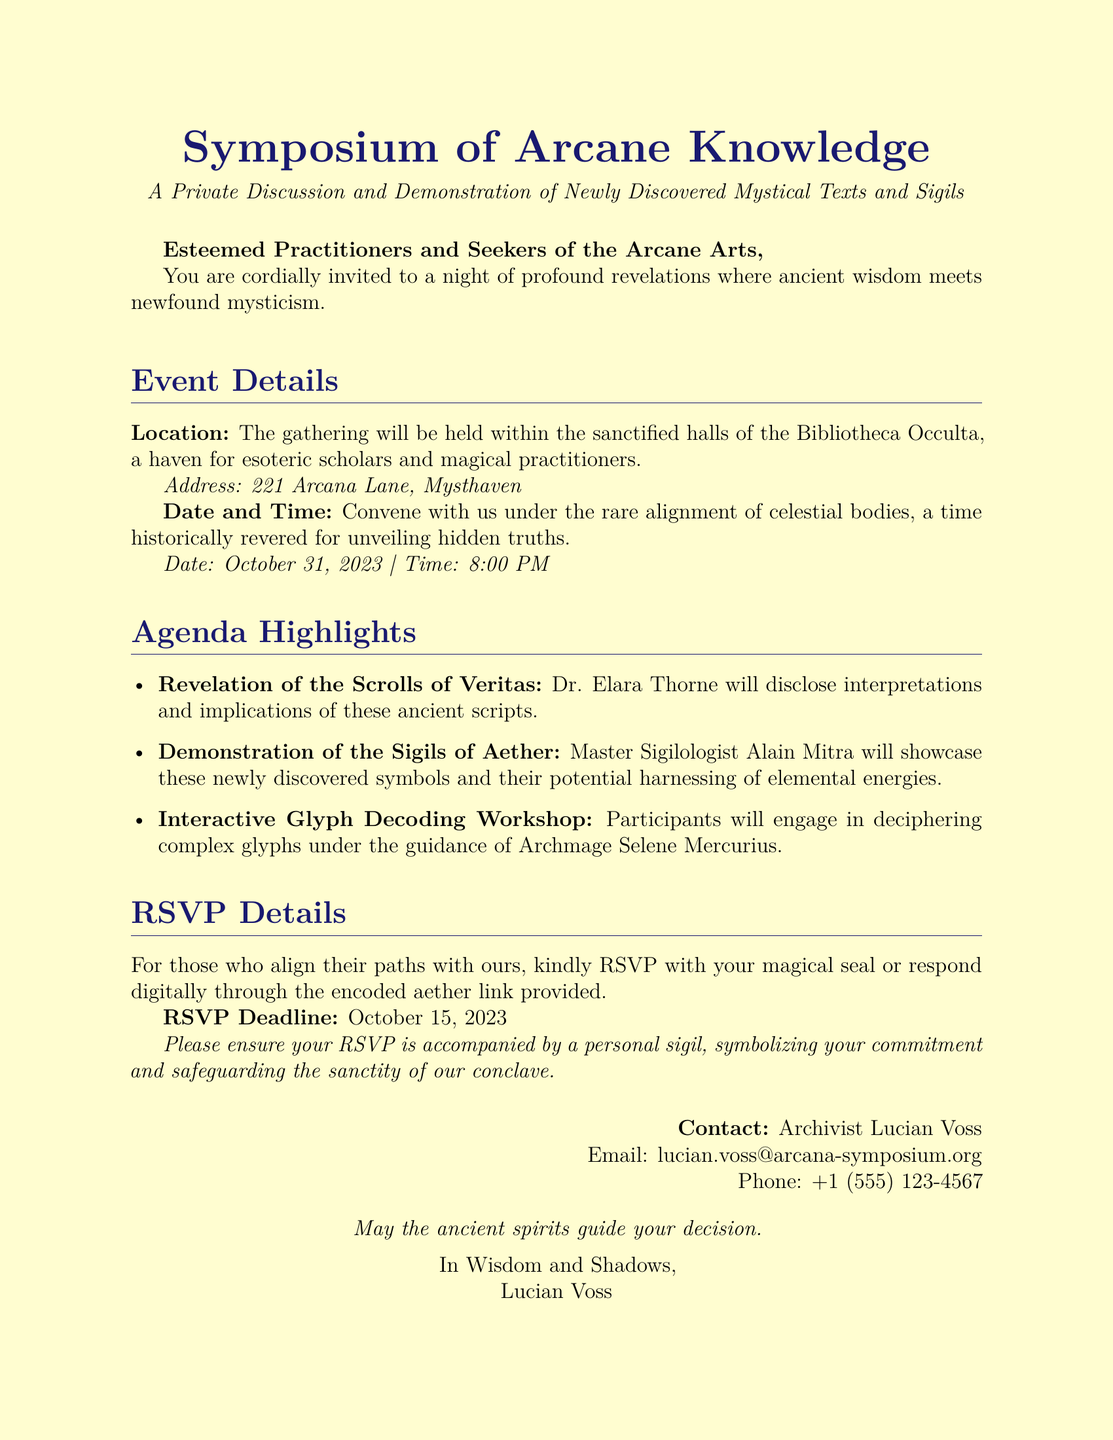what is the date of the event? The document specifies the event's date as October 31, 2023.
Answer: October 31, 2023 who is the main speaker for the Scrolls of Veritas revelation? The document names Dr. Elara Thorne as the speaker for this session.
Answer: Dr. Elara Thorne what time does the event start? The document states that the event begins at 8:00 PM.
Answer: 8:00 PM where is the event being held? The document indicates the location as the Bibliotheca Occulta.
Answer: Bibliotheca Occulta what is the RSVP deadline? The document specifies that the RSVP deadline is October 15, 2023.
Answer: October 15, 2023 which ancient symbols will be demonstrated at the symposium? The document mentions the Sigils of Aether as the symbols being showcased.
Answer: Sigils of Aether what must be included with the RSVP? The document states a personal sigil should accompany the RSVP.
Answer: Personal sigil who should be contacted for inquiries? The document lists Archivist Lucian Voss as the contact person.
Answer: Archivist Lucian Voss 